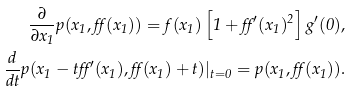Convert formula to latex. <formula><loc_0><loc_0><loc_500><loc_500>\frac { \partial } { \partial x _ { 1 } } p ( x _ { 1 } , \alpha ( x _ { 1 } ) ) = f ( x _ { 1 } ) \left [ 1 + \alpha ^ { \prime } ( x _ { 1 } ) ^ { 2 } \right ] g ^ { \prime } ( 0 ) , \\ \frac { d } { d t } p ( x _ { 1 } - t \alpha ^ { \prime } ( x _ { 1 } ) , \alpha ( x _ { 1 } ) + t ) | _ { t = 0 } = p ( x _ { 1 } , \alpha ( x _ { 1 } ) ) .</formula> 